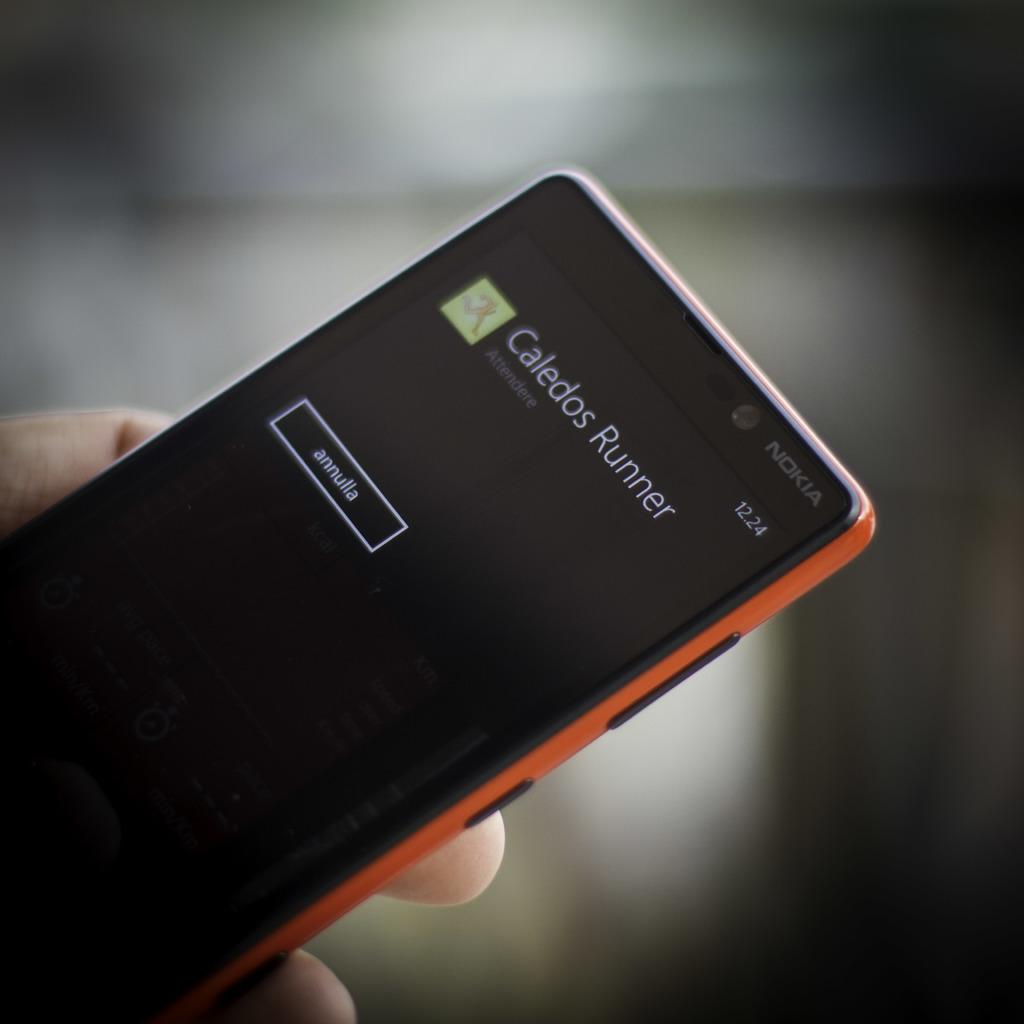<image>
Present a compact description of the photo's key features. A red smart phone that shows Caledos Runner on the screen. 